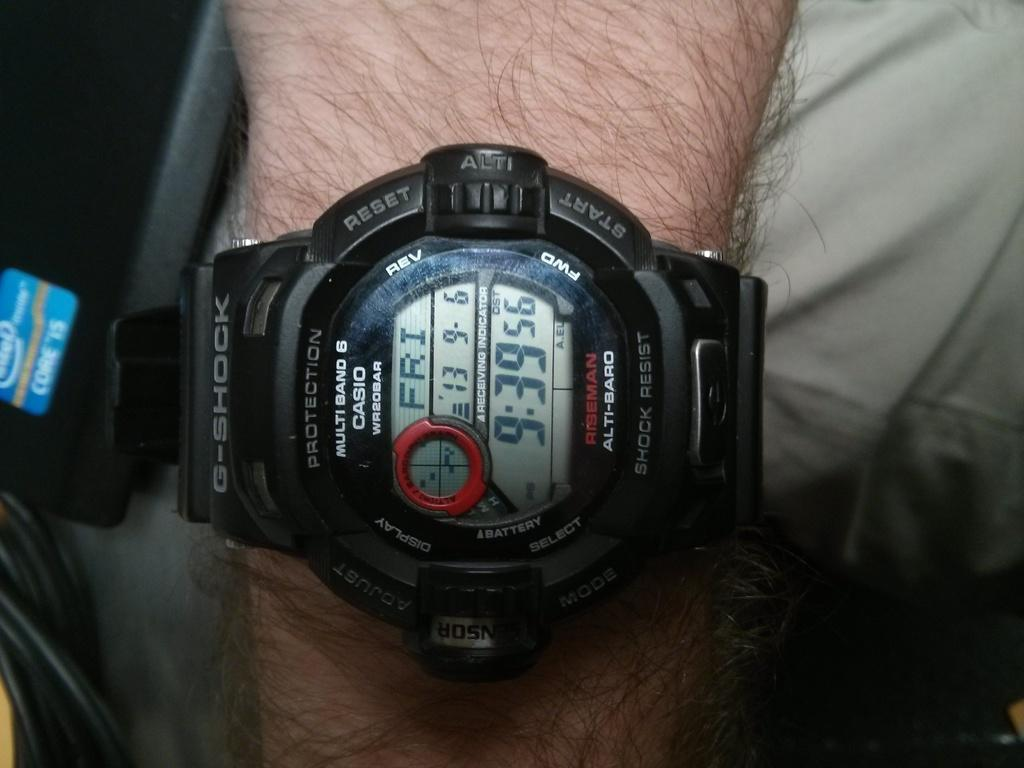<image>
Create a compact narrative representing the image presented. A black G-shock watch made by Casio is on a hairy wrist and tells us it is 9.39 on friday. 